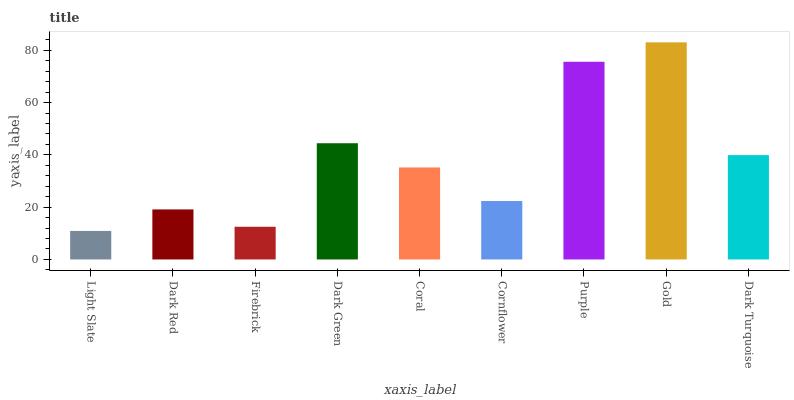Is Light Slate the minimum?
Answer yes or no. Yes. Is Gold the maximum?
Answer yes or no. Yes. Is Dark Red the minimum?
Answer yes or no. No. Is Dark Red the maximum?
Answer yes or no. No. Is Dark Red greater than Light Slate?
Answer yes or no. Yes. Is Light Slate less than Dark Red?
Answer yes or no. Yes. Is Light Slate greater than Dark Red?
Answer yes or no. No. Is Dark Red less than Light Slate?
Answer yes or no. No. Is Coral the high median?
Answer yes or no. Yes. Is Coral the low median?
Answer yes or no. Yes. Is Dark Red the high median?
Answer yes or no. No. Is Firebrick the low median?
Answer yes or no. No. 